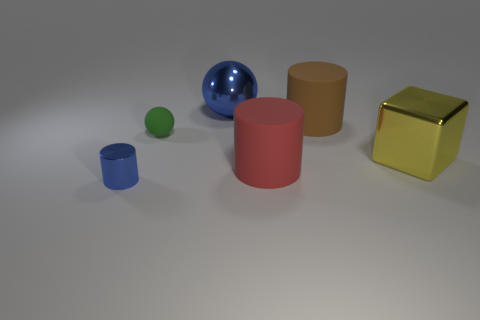Is the blue thing that is behind the large red cylinder made of the same material as the green object?
Make the answer very short. No. How many cylinders are either small blue rubber things or blue objects?
Offer a terse response. 1. What shape is the blue object that is on the right side of the ball on the left side of the blue object that is behind the big brown matte cylinder?
Your answer should be compact. Sphere. There is another object that is the same color as the small shiny thing; what is its shape?
Offer a terse response. Sphere. How many things have the same size as the green sphere?
Offer a terse response. 1. There is a big cylinder that is in front of the yellow block; are there any big things left of it?
Make the answer very short. Yes. What number of objects are large metallic spheres or tiny green balls?
Keep it short and to the point. 2. What is the color of the big matte cylinder that is behind the sphere left of the metallic thing behind the metallic cube?
Offer a very short reply. Brown. Is there anything else that has the same color as the tiny metallic cylinder?
Provide a succinct answer. Yes. Does the brown cylinder have the same size as the rubber ball?
Make the answer very short. No. 